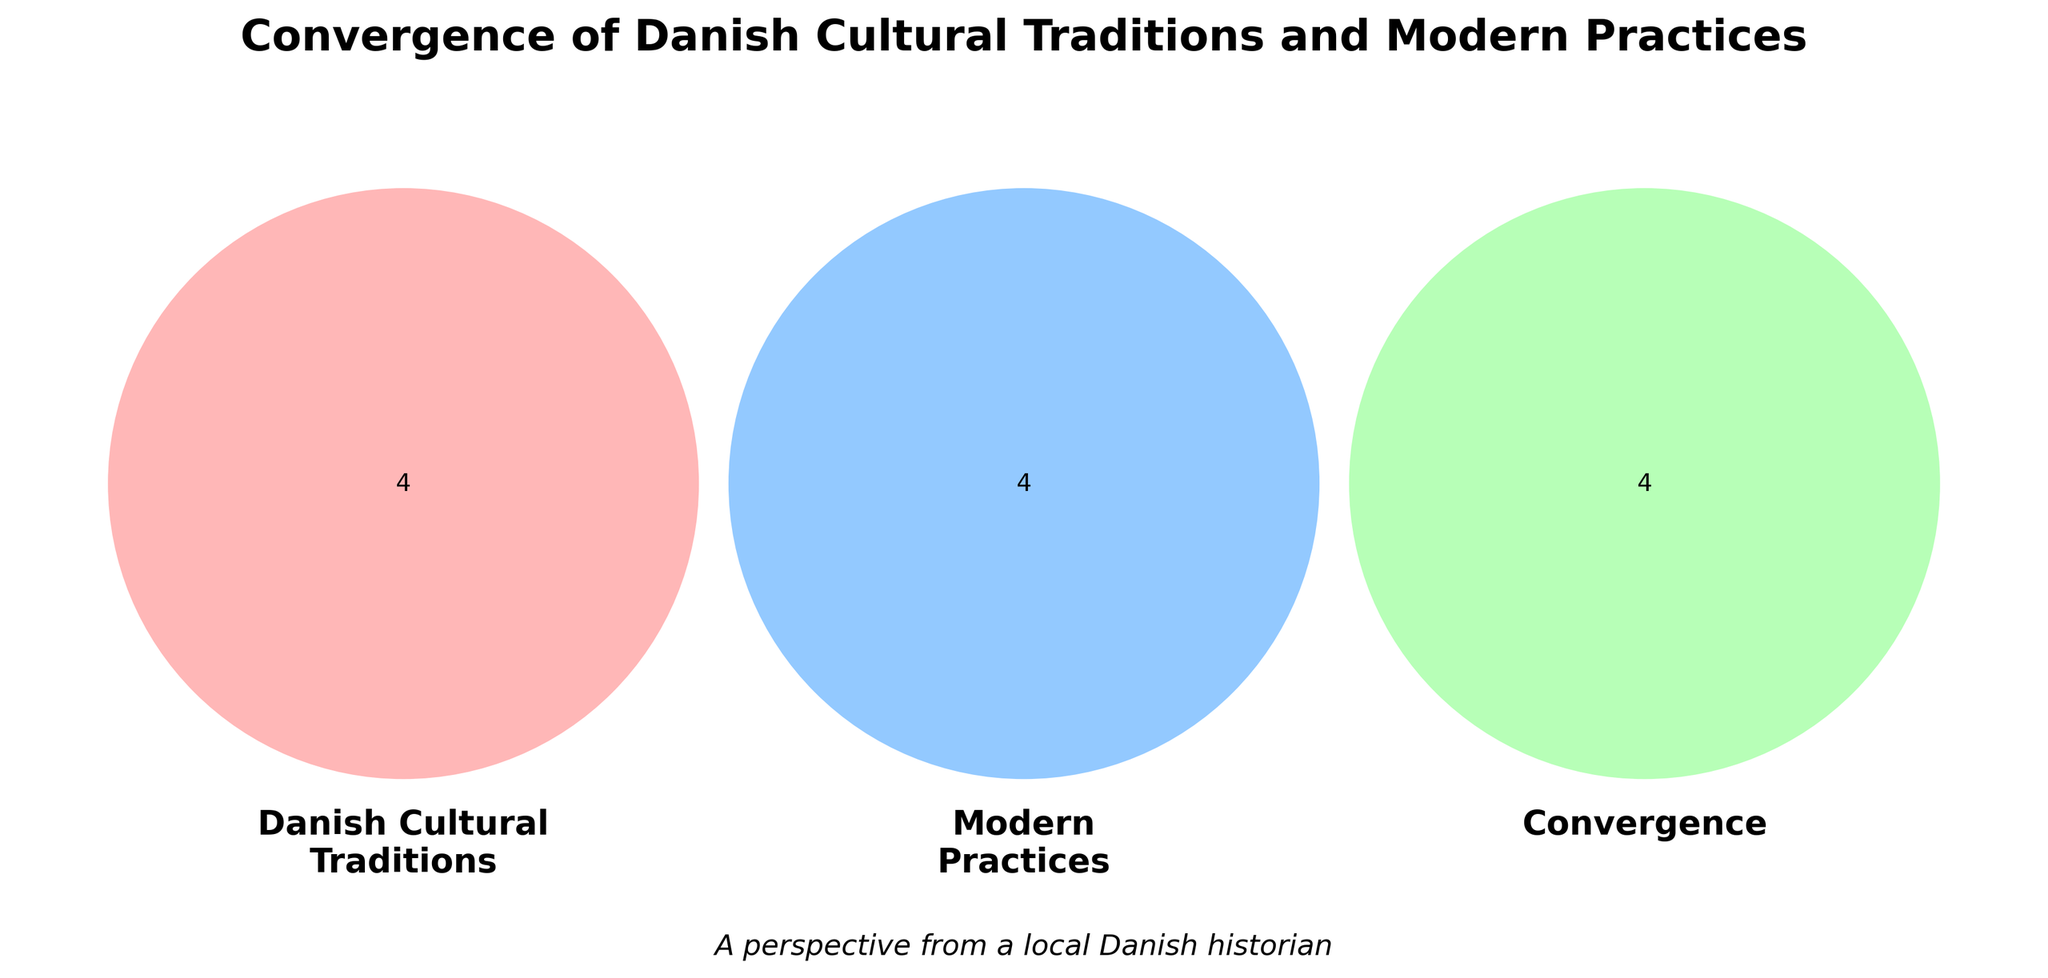What is the title of the figure? The title is usually placed at the top of the diagram. It provides an overview of what the diagram represents.
Answer: Convergence of Danish Cultural Traditions and Modern Practices What are the labels of the three sets in the Venn diagram? Venn diagram labels are typically found near each circle. These labels indicate what each set represents.
Answer: Danish Cultural Traditions, Modern Practices, Convergence Which color represents 'Danish Cultural Traditions'? Colors in a Venn diagram help to differentiate between the different sets. The color associated with 'Danish Cultural Traditions' is derived from the diagram's legend or visual appearance.
Answer: Red How many items are in the intersection of 'Danish Cultural Traditions' and 'Modern Practices'? Count the number of items listed in the intersection area between the two sets.
Answer: 0 What are the elements in the 'Convergence' set? Elements in 'Convergence' are located in the middle section where all three circles overlap.
Answer: Hygge lifestyle, Danish design, New Nordic Cuisine, Roskilde Festival How many items belong only to the 'Modern Practices' set? Look at the section of the 'Modern Practices' circle that does not overlap with any other circle. Count the items there.
Answer: 4 Identify one element common to both 'Danish Cultural Traditions' and 'Convergence'. Elements common to both sets are found in the overlapping section between these two circles.
Answer: None Compare the number of items in the 'Danish Cultural Traditions' to the 'Modern Practices'. Which has more items? Count the items in both the 'Danish Cultural Traditions' and 'Modern Practices' and compare the numbers.
Answer: Modern Practices What is one cultural tradition listed under 'Danish Cultural Traditions'? Cultural traditions listed under 'Danish Cultural Traditions' can be found in the non-overlapping section of its circle.
Answer: Tivoli Gardens 